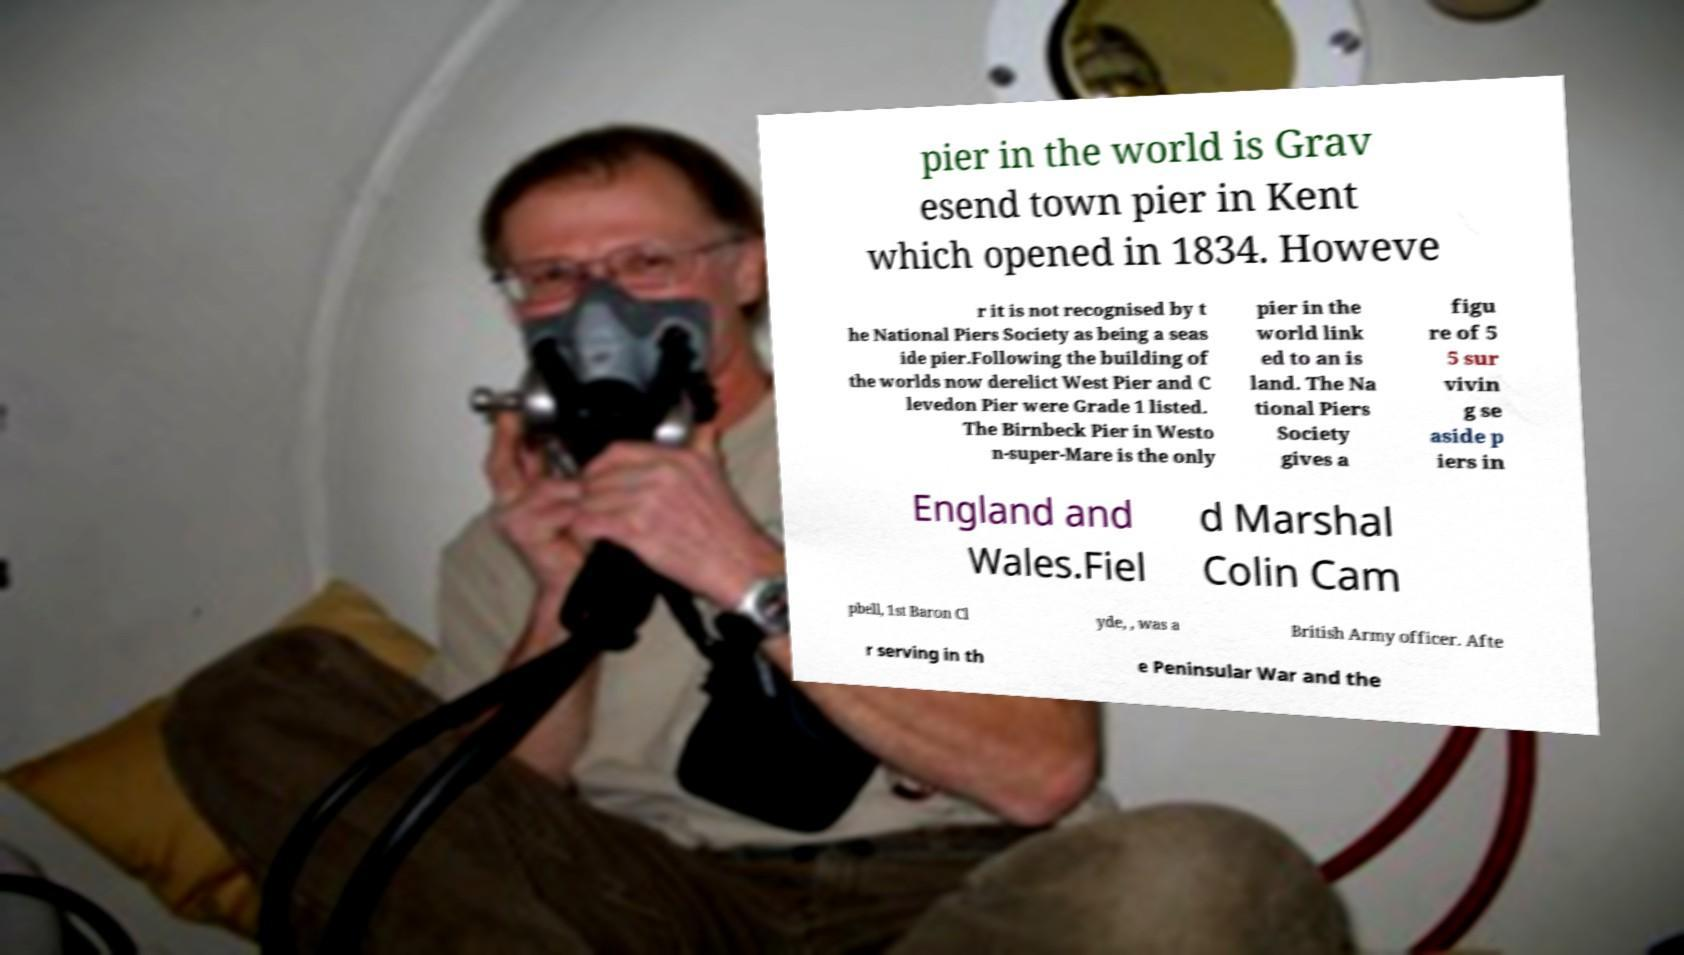Can you read and provide the text displayed in the image?This photo seems to have some interesting text. Can you extract and type it out for me? pier in the world is Grav esend town pier in Kent which opened in 1834. Howeve r it is not recognised by t he National Piers Society as being a seas ide pier.Following the building of the worlds now derelict West Pier and C levedon Pier were Grade 1 listed. The Birnbeck Pier in Westo n-super-Mare is the only pier in the world link ed to an is land. The Na tional Piers Society gives a figu re of 5 5 sur vivin g se aside p iers in England and Wales.Fiel d Marshal Colin Cam pbell, 1st Baron Cl yde, , was a British Army officer. Afte r serving in th e Peninsular War and the 